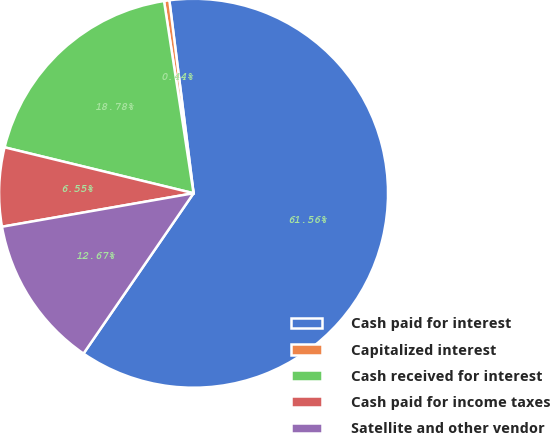<chart> <loc_0><loc_0><loc_500><loc_500><pie_chart><fcel>Cash paid for interest<fcel>Capitalized interest<fcel>Cash received for interest<fcel>Cash paid for income taxes<fcel>Satellite and other vendor<nl><fcel>61.56%<fcel>0.44%<fcel>18.78%<fcel>6.55%<fcel>12.67%<nl></chart> 